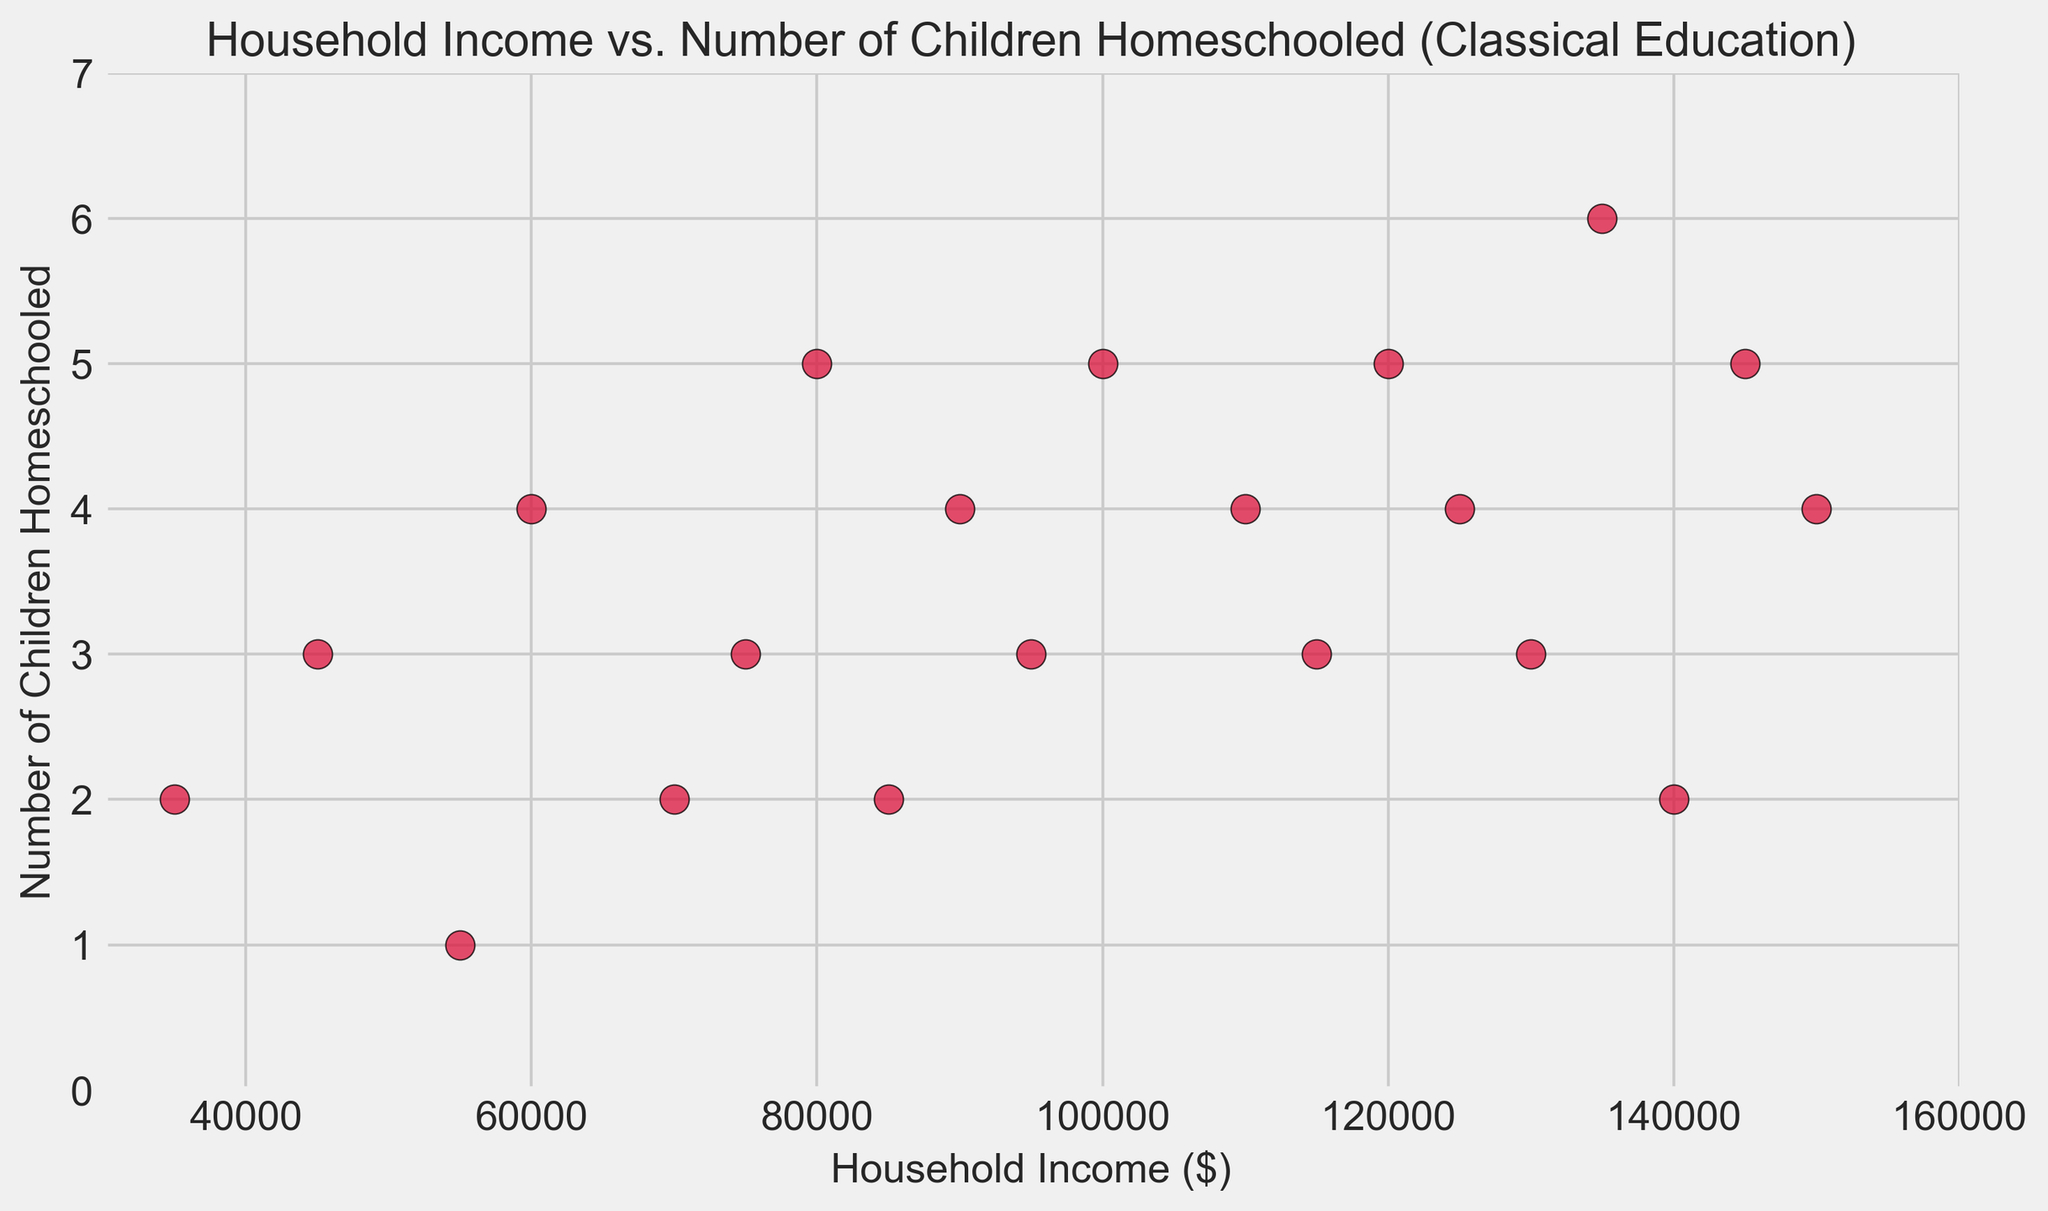What is the range of household income values displayed in the plot? The plot's x-axis ranges from $30,000 to $160,000. This indicates that the household income values span from $35,000 to $150,000.
Answer: $35,000 to $150,000 What is the most common number of children homeschooled across various income levels? By examining the y-axis, it is clear that the most frequently occurring number of children homeschooled is 4, as there are the most data points at y = 4.
Answer: 4 Which income level has the highest number of children homeschooled? Observing the y-axis values, the highest on the plot is 6 children. This corresponds to a household income of $135,000.
Answer: $135,000 How many households with an income of $90,000 are represented, and how many children are homeschooled in those households? The plot shows a single data point at an income of $90,000, which corresponds to 4 children homeschooled.
Answer: 1 household, 4 children Is there a general trend noticeable between household income and the number of children homeschooled? Examining the scatter plot, it seems there is a slight tendency for higher incomes to correspond with higher numbers of children homeschooled, although there is some variability.
Answer: Higher income, more children (general trend) What is the median household income of the households that homeschool 3 children? The incomes associated with homeschooling 3 children are $45,000, $75,000, $95,000, $115,000, $130,000. Sorting these values and finding the middle: $95,000 is the median.
Answer: $95,000 Among households with at least 5 children homeschooled, what is the highest household income? The households homeschooling exactly 5 children have incomes of $80,000, $100,000, $120,000, $145,000. The highest value among these is $145,000.
Answer: $145,000 How many households with an income higher than $100,000 have more than 3 children being homeschooled? Looking above the $100,000 mark on the x-axis and checking the y-values greater than 3, there are four households visible (incomes: $110,000, $120,000, $125,000, and $145,000).
Answer: 4 households 